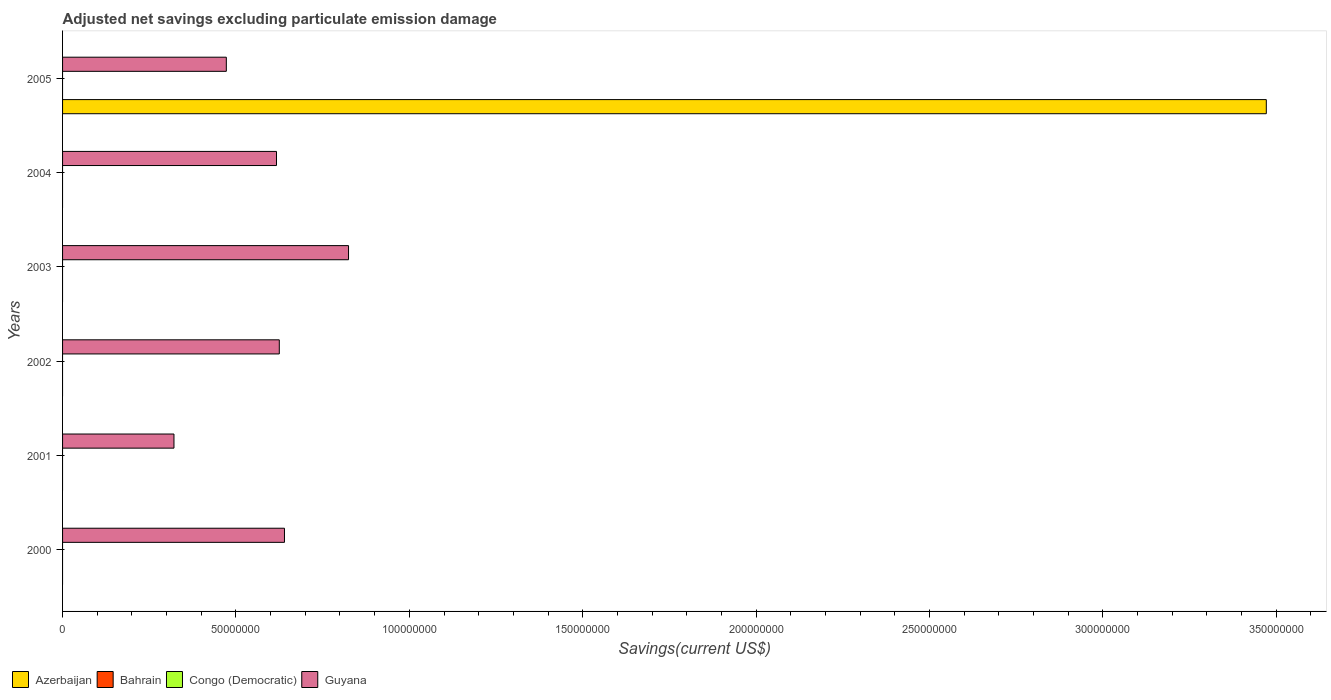How many different coloured bars are there?
Your answer should be compact. 2. Are the number of bars per tick equal to the number of legend labels?
Provide a succinct answer. No. Are the number of bars on each tick of the Y-axis equal?
Keep it short and to the point. No. How many bars are there on the 6th tick from the top?
Offer a terse response. 1. In how many cases, is the number of bars for a given year not equal to the number of legend labels?
Keep it short and to the point. 6. Across all years, what is the maximum adjusted net savings in Guyana?
Give a very brief answer. 8.25e+07. What is the total adjusted net savings in Guyana in the graph?
Your answer should be compact. 3.50e+08. What is the difference between the adjusted net savings in Guyana in 2000 and that in 2005?
Give a very brief answer. 1.68e+07. What is the difference between the adjusted net savings in Guyana in 2004 and the adjusted net savings in Bahrain in 2001?
Your answer should be very brief. 6.17e+07. What is the average adjusted net savings in Guyana per year?
Your answer should be very brief. 5.83e+07. In the year 2005, what is the difference between the adjusted net savings in Azerbaijan and adjusted net savings in Guyana?
Your answer should be compact. 3.00e+08. What is the ratio of the adjusted net savings in Guyana in 2000 to that in 2001?
Keep it short and to the point. 1.99. Is the adjusted net savings in Guyana in 2000 less than that in 2004?
Provide a short and direct response. No. What is the difference between the highest and the lowest adjusted net savings in Guyana?
Provide a short and direct response. 5.03e+07. How many bars are there?
Provide a short and direct response. 7. How many years are there in the graph?
Provide a succinct answer. 6. What is the difference between two consecutive major ticks on the X-axis?
Your answer should be compact. 5.00e+07. Where does the legend appear in the graph?
Ensure brevity in your answer.  Bottom left. How are the legend labels stacked?
Ensure brevity in your answer.  Horizontal. What is the title of the graph?
Offer a terse response. Adjusted net savings excluding particulate emission damage. What is the label or title of the X-axis?
Give a very brief answer. Savings(current US$). What is the Savings(current US$) of Bahrain in 2000?
Your response must be concise. 0. What is the Savings(current US$) of Congo (Democratic) in 2000?
Offer a very short reply. 0. What is the Savings(current US$) of Guyana in 2000?
Provide a short and direct response. 6.40e+07. What is the Savings(current US$) of Congo (Democratic) in 2001?
Make the answer very short. 0. What is the Savings(current US$) of Guyana in 2001?
Your response must be concise. 3.21e+07. What is the Savings(current US$) of Azerbaijan in 2002?
Offer a terse response. 0. What is the Savings(current US$) of Bahrain in 2002?
Keep it short and to the point. 0. What is the Savings(current US$) of Congo (Democratic) in 2002?
Ensure brevity in your answer.  0. What is the Savings(current US$) of Guyana in 2002?
Provide a short and direct response. 6.25e+07. What is the Savings(current US$) in Bahrain in 2003?
Make the answer very short. 0. What is the Savings(current US$) of Guyana in 2003?
Keep it short and to the point. 8.25e+07. What is the Savings(current US$) of Congo (Democratic) in 2004?
Provide a succinct answer. 0. What is the Savings(current US$) in Guyana in 2004?
Provide a short and direct response. 6.17e+07. What is the Savings(current US$) of Azerbaijan in 2005?
Keep it short and to the point. 3.47e+08. What is the Savings(current US$) of Congo (Democratic) in 2005?
Ensure brevity in your answer.  0. What is the Savings(current US$) in Guyana in 2005?
Offer a very short reply. 4.72e+07. Across all years, what is the maximum Savings(current US$) of Azerbaijan?
Give a very brief answer. 3.47e+08. Across all years, what is the maximum Savings(current US$) of Guyana?
Provide a succinct answer. 8.25e+07. Across all years, what is the minimum Savings(current US$) of Azerbaijan?
Provide a short and direct response. 0. Across all years, what is the minimum Savings(current US$) of Guyana?
Offer a terse response. 3.21e+07. What is the total Savings(current US$) in Azerbaijan in the graph?
Provide a short and direct response. 3.47e+08. What is the total Savings(current US$) in Congo (Democratic) in the graph?
Offer a terse response. 0. What is the total Savings(current US$) in Guyana in the graph?
Your answer should be compact. 3.50e+08. What is the difference between the Savings(current US$) in Guyana in 2000 and that in 2001?
Give a very brief answer. 3.19e+07. What is the difference between the Savings(current US$) of Guyana in 2000 and that in 2002?
Your response must be concise. 1.49e+06. What is the difference between the Savings(current US$) of Guyana in 2000 and that in 2003?
Provide a short and direct response. -1.85e+07. What is the difference between the Savings(current US$) in Guyana in 2000 and that in 2004?
Offer a very short reply. 2.30e+06. What is the difference between the Savings(current US$) of Guyana in 2000 and that in 2005?
Provide a succinct answer. 1.68e+07. What is the difference between the Savings(current US$) in Guyana in 2001 and that in 2002?
Ensure brevity in your answer.  -3.04e+07. What is the difference between the Savings(current US$) in Guyana in 2001 and that in 2003?
Your answer should be compact. -5.03e+07. What is the difference between the Savings(current US$) of Guyana in 2001 and that in 2004?
Offer a terse response. -2.96e+07. What is the difference between the Savings(current US$) of Guyana in 2001 and that in 2005?
Make the answer very short. -1.51e+07. What is the difference between the Savings(current US$) in Guyana in 2002 and that in 2003?
Give a very brief answer. -2.00e+07. What is the difference between the Savings(current US$) in Guyana in 2002 and that in 2004?
Your answer should be very brief. 8.04e+05. What is the difference between the Savings(current US$) of Guyana in 2002 and that in 2005?
Offer a very short reply. 1.53e+07. What is the difference between the Savings(current US$) of Guyana in 2003 and that in 2004?
Give a very brief answer. 2.08e+07. What is the difference between the Savings(current US$) in Guyana in 2003 and that in 2005?
Keep it short and to the point. 3.52e+07. What is the difference between the Savings(current US$) in Guyana in 2004 and that in 2005?
Your response must be concise. 1.45e+07. What is the average Savings(current US$) in Azerbaijan per year?
Make the answer very short. 5.79e+07. What is the average Savings(current US$) in Bahrain per year?
Offer a very short reply. 0. What is the average Savings(current US$) of Congo (Democratic) per year?
Offer a terse response. 0. What is the average Savings(current US$) of Guyana per year?
Your answer should be very brief. 5.83e+07. In the year 2005, what is the difference between the Savings(current US$) in Azerbaijan and Savings(current US$) in Guyana?
Ensure brevity in your answer.  3.00e+08. What is the ratio of the Savings(current US$) of Guyana in 2000 to that in 2001?
Provide a short and direct response. 1.99. What is the ratio of the Savings(current US$) of Guyana in 2000 to that in 2002?
Offer a very short reply. 1.02. What is the ratio of the Savings(current US$) in Guyana in 2000 to that in 2003?
Ensure brevity in your answer.  0.78. What is the ratio of the Savings(current US$) of Guyana in 2000 to that in 2004?
Your answer should be very brief. 1.04. What is the ratio of the Savings(current US$) of Guyana in 2000 to that in 2005?
Make the answer very short. 1.35. What is the ratio of the Savings(current US$) of Guyana in 2001 to that in 2002?
Offer a terse response. 0.51. What is the ratio of the Savings(current US$) in Guyana in 2001 to that in 2003?
Your answer should be compact. 0.39. What is the ratio of the Savings(current US$) in Guyana in 2001 to that in 2004?
Ensure brevity in your answer.  0.52. What is the ratio of the Savings(current US$) in Guyana in 2001 to that in 2005?
Provide a succinct answer. 0.68. What is the ratio of the Savings(current US$) in Guyana in 2002 to that in 2003?
Make the answer very short. 0.76. What is the ratio of the Savings(current US$) in Guyana in 2002 to that in 2004?
Your answer should be compact. 1.01. What is the ratio of the Savings(current US$) of Guyana in 2002 to that in 2005?
Ensure brevity in your answer.  1.32. What is the ratio of the Savings(current US$) of Guyana in 2003 to that in 2004?
Make the answer very short. 1.34. What is the ratio of the Savings(current US$) of Guyana in 2003 to that in 2005?
Make the answer very short. 1.75. What is the ratio of the Savings(current US$) of Guyana in 2004 to that in 2005?
Make the answer very short. 1.31. What is the difference between the highest and the second highest Savings(current US$) in Guyana?
Give a very brief answer. 1.85e+07. What is the difference between the highest and the lowest Savings(current US$) of Azerbaijan?
Provide a short and direct response. 3.47e+08. What is the difference between the highest and the lowest Savings(current US$) of Guyana?
Make the answer very short. 5.03e+07. 